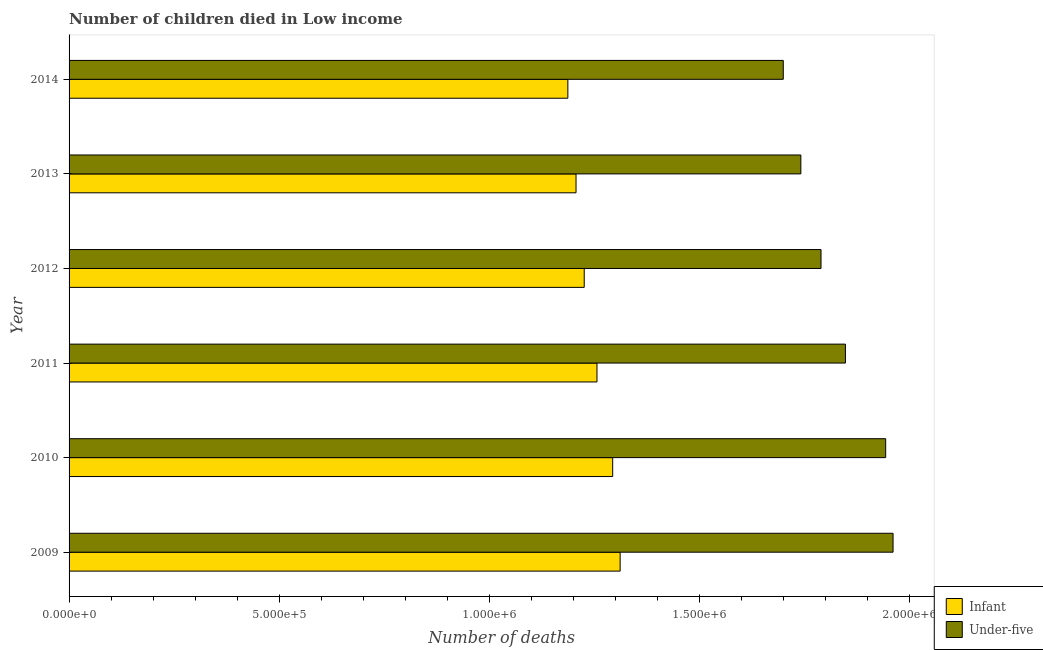How many groups of bars are there?
Make the answer very short. 6. How many bars are there on the 6th tick from the top?
Ensure brevity in your answer.  2. How many bars are there on the 5th tick from the bottom?
Give a very brief answer. 2. What is the label of the 6th group of bars from the top?
Ensure brevity in your answer.  2009. What is the number of infant deaths in 2013?
Your answer should be compact. 1.21e+06. Across all years, what is the maximum number of infant deaths?
Give a very brief answer. 1.31e+06. Across all years, what is the minimum number of under-five deaths?
Offer a terse response. 1.70e+06. What is the total number of infant deaths in the graph?
Make the answer very short. 7.48e+06. What is the difference between the number of infant deaths in 2010 and that in 2012?
Your response must be concise. 6.78e+04. What is the difference between the number of infant deaths in 2010 and the number of under-five deaths in 2011?
Make the answer very short. -5.54e+05. What is the average number of under-five deaths per year?
Your response must be concise. 1.83e+06. In the year 2012, what is the difference between the number of infant deaths and number of under-five deaths?
Give a very brief answer. -5.64e+05. What is the ratio of the number of infant deaths in 2009 to that in 2013?
Provide a short and direct response. 1.09. Is the difference between the number of under-five deaths in 2009 and 2013 greater than the difference between the number of infant deaths in 2009 and 2013?
Keep it short and to the point. Yes. What is the difference between the highest and the second highest number of under-five deaths?
Make the answer very short. 1.76e+04. What is the difference between the highest and the lowest number of under-five deaths?
Offer a very short reply. 2.61e+05. Is the sum of the number of under-five deaths in 2011 and 2013 greater than the maximum number of infant deaths across all years?
Offer a terse response. Yes. What does the 2nd bar from the top in 2010 represents?
Offer a very short reply. Infant. What does the 2nd bar from the bottom in 2011 represents?
Your answer should be very brief. Under-five. How many bars are there?
Ensure brevity in your answer.  12. Are all the bars in the graph horizontal?
Your answer should be compact. Yes. How many years are there in the graph?
Make the answer very short. 6. What is the difference between two consecutive major ticks on the X-axis?
Offer a very short reply. 5.00e+05. Are the values on the major ticks of X-axis written in scientific E-notation?
Offer a terse response. Yes. Does the graph contain any zero values?
Your answer should be very brief. No. Does the graph contain grids?
Your answer should be compact. No. How are the legend labels stacked?
Keep it short and to the point. Vertical. What is the title of the graph?
Keep it short and to the point. Number of children died in Low income. Does "Resident workers" appear as one of the legend labels in the graph?
Offer a terse response. No. What is the label or title of the X-axis?
Keep it short and to the point. Number of deaths. What is the label or title of the Y-axis?
Give a very brief answer. Year. What is the Number of deaths of Infant in 2009?
Your response must be concise. 1.31e+06. What is the Number of deaths of Under-five in 2009?
Provide a short and direct response. 1.96e+06. What is the Number of deaths in Infant in 2010?
Ensure brevity in your answer.  1.29e+06. What is the Number of deaths in Under-five in 2010?
Your answer should be very brief. 1.94e+06. What is the Number of deaths in Infant in 2011?
Provide a short and direct response. 1.26e+06. What is the Number of deaths in Under-five in 2011?
Make the answer very short. 1.85e+06. What is the Number of deaths in Infant in 2012?
Ensure brevity in your answer.  1.23e+06. What is the Number of deaths in Under-five in 2012?
Ensure brevity in your answer.  1.79e+06. What is the Number of deaths in Infant in 2013?
Keep it short and to the point. 1.21e+06. What is the Number of deaths in Under-five in 2013?
Ensure brevity in your answer.  1.74e+06. What is the Number of deaths of Infant in 2014?
Offer a terse response. 1.19e+06. What is the Number of deaths of Under-five in 2014?
Give a very brief answer. 1.70e+06. Across all years, what is the maximum Number of deaths of Infant?
Your answer should be very brief. 1.31e+06. Across all years, what is the maximum Number of deaths of Under-five?
Provide a short and direct response. 1.96e+06. Across all years, what is the minimum Number of deaths of Infant?
Make the answer very short. 1.19e+06. Across all years, what is the minimum Number of deaths in Under-five?
Make the answer very short. 1.70e+06. What is the total Number of deaths in Infant in the graph?
Make the answer very short. 7.48e+06. What is the total Number of deaths of Under-five in the graph?
Make the answer very short. 1.10e+07. What is the difference between the Number of deaths of Infant in 2009 and that in 2010?
Provide a short and direct response. 1.77e+04. What is the difference between the Number of deaths in Under-five in 2009 and that in 2010?
Your answer should be compact. 1.76e+04. What is the difference between the Number of deaths of Infant in 2009 and that in 2011?
Provide a short and direct response. 5.51e+04. What is the difference between the Number of deaths of Under-five in 2009 and that in 2011?
Your answer should be very brief. 1.13e+05. What is the difference between the Number of deaths in Infant in 2009 and that in 2012?
Your response must be concise. 8.55e+04. What is the difference between the Number of deaths in Under-five in 2009 and that in 2012?
Offer a terse response. 1.71e+05. What is the difference between the Number of deaths in Infant in 2009 and that in 2013?
Your answer should be compact. 1.05e+05. What is the difference between the Number of deaths of Under-five in 2009 and that in 2013?
Offer a very short reply. 2.19e+05. What is the difference between the Number of deaths of Infant in 2009 and that in 2014?
Your answer should be compact. 1.24e+05. What is the difference between the Number of deaths in Under-five in 2009 and that in 2014?
Offer a very short reply. 2.61e+05. What is the difference between the Number of deaths in Infant in 2010 and that in 2011?
Offer a terse response. 3.73e+04. What is the difference between the Number of deaths in Under-five in 2010 and that in 2011?
Your response must be concise. 9.58e+04. What is the difference between the Number of deaths in Infant in 2010 and that in 2012?
Offer a terse response. 6.78e+04. What is the difference between the Number of deaths in Under-five in 2010 and that in 2012?
Keep it short and to the point. 1.54e+05. What is the difference between the Number of deaths in Infant in 2010 and that in 2013?
Give a very brief answer. 8.72e+04. What is the difference between the Number of deaths of Under-five in 2010 and that in 2013?
Your response must be concise. 2.02e+05. What is the difference between the Number of deaths in Infant in 2010 and that in 2014?
Provide a succinct answer. 1.07e+05. What is the difference between the Number of deaths in Under-five in 2010 and that in 2014?
Offer a terse response. 2.44e+05. What is the difference between the Number of deaths in Infant in 2011 and that in 2012?
Keep it short and to the point. 3.04e+04. What is the difference between the Number of deaths in Under-five in 2011 and that in 2012?
Offer a very short reply. 5.81e+04. What is the difference between the Number of deaths of Infant in 2011 and that in 2013?
Keep it short and to the point. 4.99e+04. What is the difference between the Number of deaths in Under-five in 2011 and that in 2013?
Your answer should be very brief. 1.06e+05. What is the difference between the Number of deaths of Infant in 2011 and that in 2014?
Offer a terse response. 6.93e+04. What is the difference between the Number of deaths in Under-five in 2011 and that in 2014?
Your answer should be very brief. 1.48e+05. What is the difference between the Number of deaths in Infant in 2012 and that in 2013?
Your answer should be compact. 1.95e+04. What is the difference between the Number of deaths of Under-five in 2012 and that in 2013?
Offer a very short reply. 4.80e+04. What is the difference between the Number of deaths of Infant in 2012 and that in 2014?
Offer a very short reply. 3.89e+04. What is the difference between the Number of deaths of Under-five in 2012 and that in 2014?
Ensure brevity in your answer.  8.98e+04. What is the difference between the Number of deaths of Infant in 2013 and that in 2014?
Provide a succinct answer. 1.95e+04. What is the difference between the Number of deaths in Under-five in 2013 and that in 2014?
Your answer should be very brief. 4.19e+04. What is the difference between the Number of deaths of Infant in 2009 and the Number of deaths of Under-five in 2010?
Offer a very short reply. -6.32e+05. What is the difference between the Number of deaths in Infant in 2009 and the Number of deaths in Under-five in 2011?
Your answer should be compact. -5.36e+05. What is the difference between the Number of deaths of Infant in 2009 and the Number of deaths of Under-five in 2012?
Provide a short and direct response. -4.78e+05. What is the difference between the Number of deaths of Infant in 2009 and the Number of deaths of Under-five in 2013?
Offer a terse response. -4.30e+05. What is the difference between the Number of deaths in Infant in 2009 and the Number of deaths in Under-five in 2014?
Give a very brief answer. -3.88e+05. What is the difference between the Number of deaths in Infant in 2010 and the Number of deaths in Under-five in 2011?
Make the answer very short. -5.54e+05. What is the difference between the Number of deaths of Infant in 2010 and the Number of deaths of Under-five in 2012?
Offer a very short reply. -4.96e+05. What is the difference between the Number of deaths in Infant in 2010 and the Number of deaths in Under-five in 2013?
Provide a short and direct response. -4.48e+05. What is the difference between the Number of deaths of Infant in 2010 and the Number of deaths of Under-five in 2014?
Provide a short and direct response. -4.06e+05. What is the difference between the Number of deaths in Infant in 2011 and the Number of deaths in Under-five in 2012?
Your answer should be very brief. -5.33e+05. What is the difference between the Number of deaths in Infant in 2011 and the Number of deaths in Under-five in 2013?
Give a very brief answer. -4.85e+05. What is the difference between the Number of deaths in Infant in 2011 and the Number of deaths in Under-five in 2014?
Your answer should be very brief. -4.43e+05. What is the difference between the Number of deaths of Infant in 2012 and the Number of deaths of Under-five in 2013?
Keep it short and to the point. -5.16e+05. What is the difference between the Number of deaths in Infant in 2012 and the Number of deaths in Under-five in 2014?
Your answer should be very brief. -4.74e+05. What is the difference between the Number of deaths in Infant in 2013 and the Number of deaths in Under-five in 2014?
Offer a very short reply. -4.93e+05. What is the average Number of deaths of Infant per year?
Ensure brevity in your answer.  1.25e+06. What is the average Number of deaths of Under-five per year?
Provide a short and direct response. 1.83e+06. In the year 2009, what is the difference between the Number of deaths in Infant and Number of deaths in Under-five?
Provide a short and direct response. -6.50e+05. In the year 2010, what is the difference between the Number of deaths in Infant and Number of deaths in Under-five?
Your answer should be compact. -6.50e+05. In the year 2011, what is the difference between the Number of deaths of Infant and Number of deaths of Under-five?
Your answer should be very brief. -5.91e+05. In the year 2012, what is the difference between the Number of deaths in Infant and Number of deaths in Under-five?
Give a very brief answer. -5.64e+05. In the year 2013, what is the difference between the Number of deaths of Infant and Number of deaths of Under-five?
Provide a succinct answer. -5.35e+05. In the year 2014, what is the difference between the Number of deaths of Infant and Number of deaths of Under-five?
Keep it short and to the point. -5.13e+05. What is the ratio of the Number of deaths in Infant in 2009 to that in 2010?
Offer a very short reply. 1.01. What is the ratio of the Number of deaths in Infant in 2009 to that in 2011?
Make the answer very short. 1.04. What is the ratio of the Number of deaths in Under-five in 2009 to that in 2011?
Provide a succinct answer. 1.06. What is the ratio of the Number of deaths in Infant in 2009 to that in 2012?
Offer a terse response. 1.07. What is the ratio of the Number of deaths of Under-five in 2009 to that in 2012?
Provide a succinct answer. 1.1. What is the ratio of the Number of deaths in Infant in 2009 to that in 2013?
Make the answer very short. 1.09. What is the ratio of the Number of deaths in Under-five in 2009 to that in 2013?
Offer a very short reply. 1.13. What is the ratio of the Number of deaths of Infant in 2009 to that in 2014?
Your answer should be compact. 1.1. What is the ratio of the Number of deaths of Under-five in 2009 to that in 2014?
Your answer should be compact. 1.15. What is the ratio of the Number of deaths in Infant in 2010 to that in 2011?
Offer a very short reply. 1.03. What is the ratio of the Number of deaths in Under-five in 2010 to that in 2011?
Keep it short and to the point. 1.05. What is the ratio of the Number of deaths of Infant in 2010 to that in 2012?
Your answer should be very brief. 1.06. What is the ratio of the Number of deaths of Under-five in 2010 to that in 2012?
Ensure brevity in your answer.  1.09. What is the ratio of the Number of deaths in Infant in 2010 to that in 2013?
Your answer should be very brief. 1.07. What is the ratio of the Number of deaths in Under-five in 2010 to that in 2013?
Offer a very short reply. 1.12. What is the ratio of the Number of deaths in Infant in 2010 to that in 2014?
Provide a succinct answer. 1.09. What is the ratio of the Number of deaths of Under-five in 2010 to that in 2014?
Your answer should be very brief. 1.14. What is the ratio of the Number of deaths of Infant in 2011 to that in 2012?
Ensure brevity in your answer.  1.02. What is the ratio of the Number of deaths of Under-five in 2011 to that in 2012?
Keep it short and to the point. 1.03. What is the ratio of the Number of deaths of Infant in 2011 to that in 2013?
Provide a short and direct response. 1.04. What is the ratio of the Number of deaths in Under-five in 2011 to that in 2013?
Provide a succinct answer. 1.06. What is the ratio of the Number of deaths in Infant in 2011 to that in 2014?
Offer a very short reply. 1.06. What is the ratio of the Number of deaths of Under-five in 2011 to that in 2014?
Make the answer very short. 1.09. What is the ratio of the Number of deaths in Infant in 2012 to that in 2013?
Give a very brief answer. 1.02. What is the ratio of the Number of deaths of Under-five in 2012 to that in 2013?
Give a very brief answer. 1.03. What is the ratio of the Number of deaths in Infant in 2012 to that in 2014?
Offer a very short reply. 1.03. What is the ratio of the Number of deaths of Under-five in 2012 to that in 2014?
Provide a short and direct response. 1.05. What is the ratio of the Number of deaths in Infant in 2013 to that in 2014?
Provide a succinct answer. 1.02. What is the ratio of the Number of deaths in Under-five in 2013 to that in 2014?
Provide a succinct answer. 1.02. What is the difference between the highest and the second highest Number of deaths in Infant?
Offer a very short reply. 1.77e+04. What is the difference between the highest and the second highest Number of deaths of Under-five?
Your answer should be very brief. 1.76e+04. What is the difference between the highest and the lowest Number of deaths in Infant?
Your answer should be very brief. 1.24e+05. What is the difference between the highest and the lowest Number of deaths in Under-five?
Give a very brief answer. 2.61e+05. 